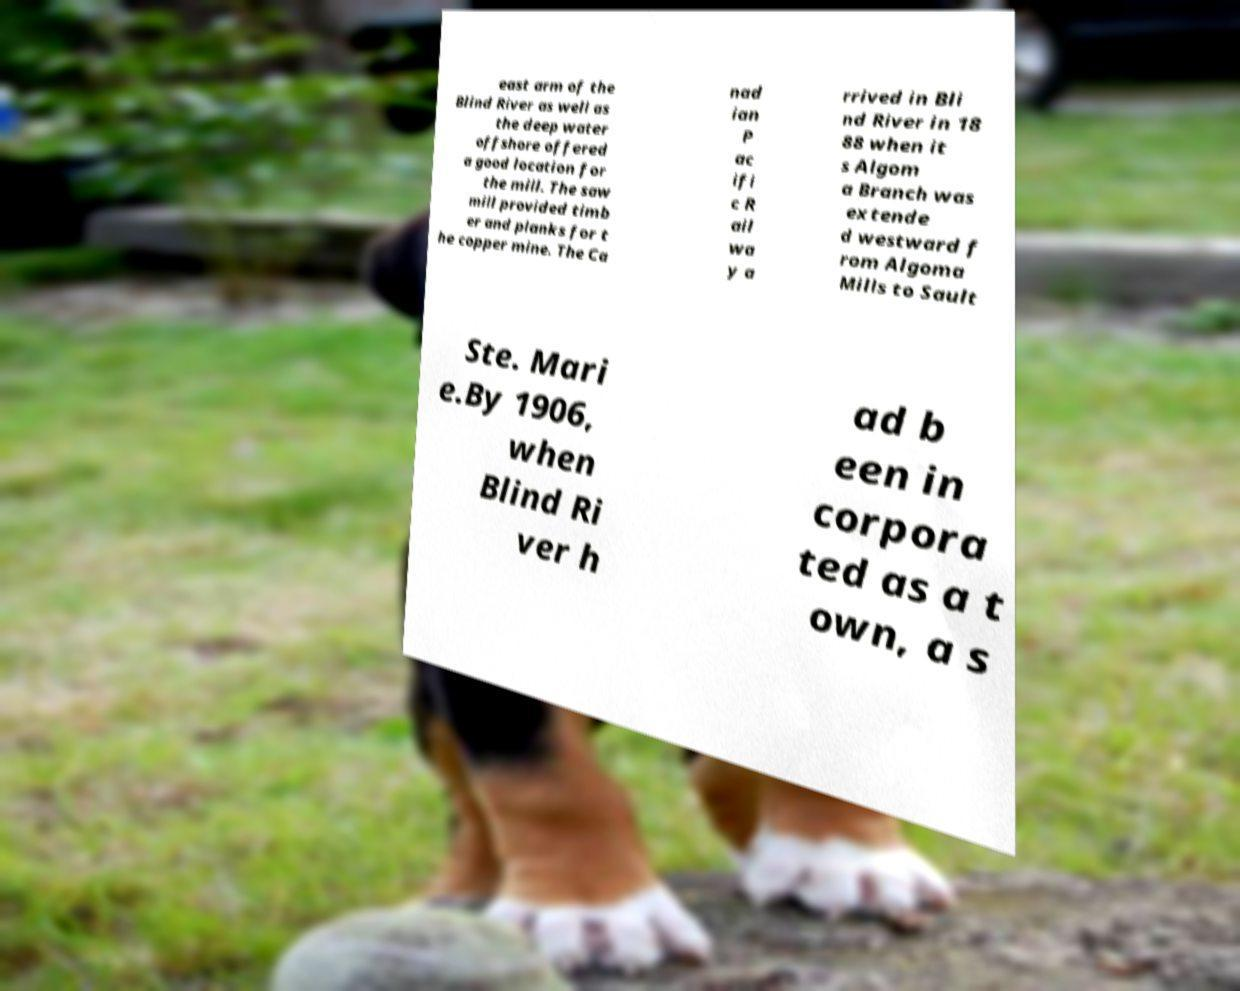What messages or text are displayed in this image? I need them in a readable, typed format. east arm of the Blind River as well as the deep water offshore offered a good location for the mill. The saw mill provided timb er and planks for t he copper mine. The Ca nad ian P ac ifi c R ail wa y a rrived in Bli nd River in 18 88 when it s Algom a Branch was extende d westward f rom Algoma Mills to Sault Ste. Mari e.By 1906, when Blind Ri ver h ad b een in corpora ted as a t own, a s 